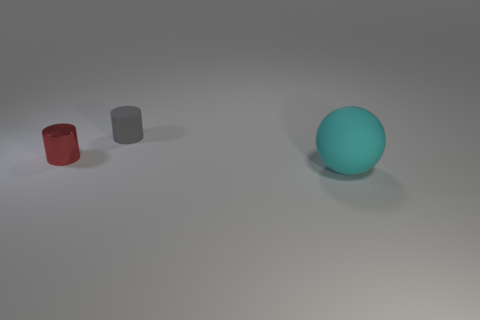Add 2 green objects. How many objects exist? 5 Subtract all cylinders. How many objects are left? 1 Add 2 tiny gray matte objects. How many tiny gray matte objects are left? 3 Add 3 tiny gray rubber things. How many tiny gray rubber things exist? 4 Subtract 0 yellow blocks. How many objects are left? 3 Subtract all big cyan rubber objects. Subtract all small red cylinders. How many objects are left? 1 